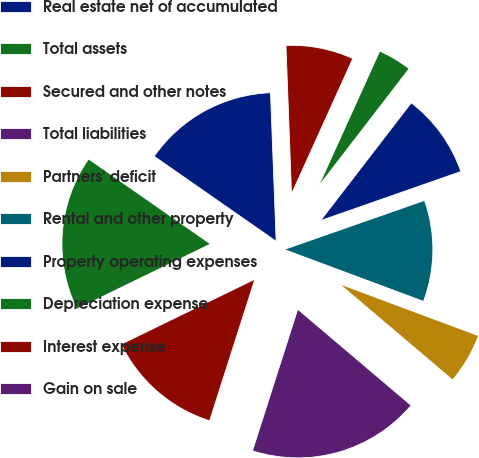<chart> <loc_0><loc_0><loc_500><loc_500><pie_chart><fcel>Real estate net of accumulated<fcel>Total assets<fcel>Secured and other notes<fcel>Total liabilities<fcel>Partners' deficit<fcel>Rental and other property<fcel>Property operating expenses<fcel>Depreciation expense<fcel>Interest expense<fcel>Gain on sale<nl><fcel>14.71%<fcel>16.89%<fcel>12.87%<fcel>18.73%<fcel>5.52%<fcel>11.03%<fcel>9.2%<fcel>3.68%<fcel>7.36%<fcel>0.01%<nl></chart> 